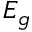Convert formula to latex. <formula><loc_0><loc_0><loc_500><loc_500>E _ { g }</formula> 